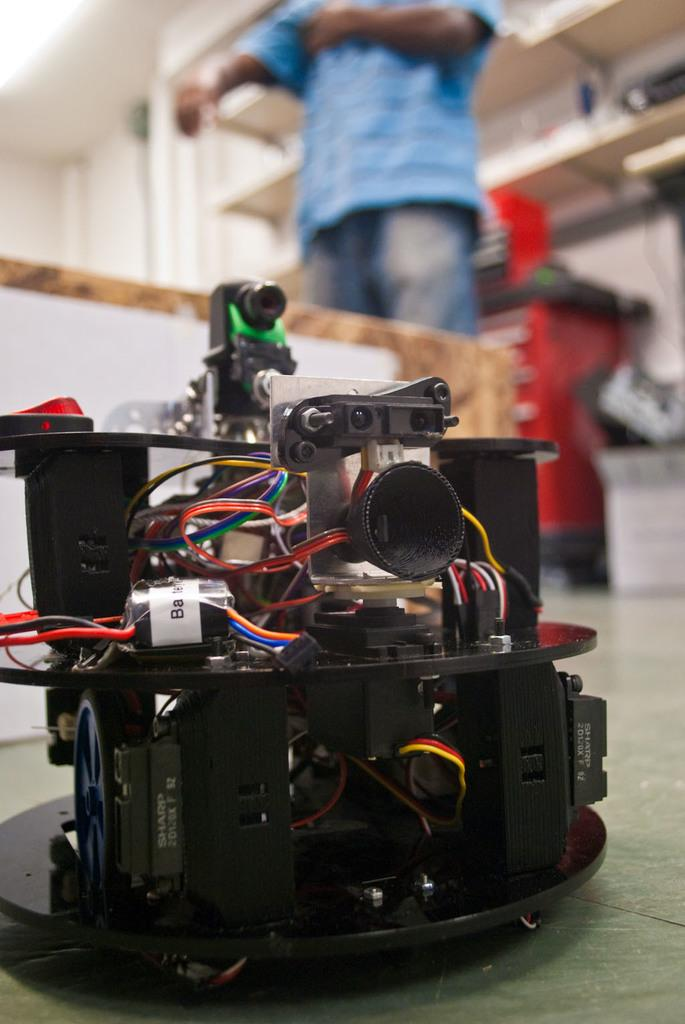What type of object is located at the bottom of the image? There is an electrical device in the image, and it is at the bottom. Can you describe the person in the image? There is a person in the image, but their appearance or actions are not specified in the provided facts. What can be seen at the top of the image? There are racks at the top of the image. Can you describe the person's breathing pattern in the image? There is no information about the person's breathing pattern in the image, as the provided facts do not mention any details about the person's actions or expressions. 